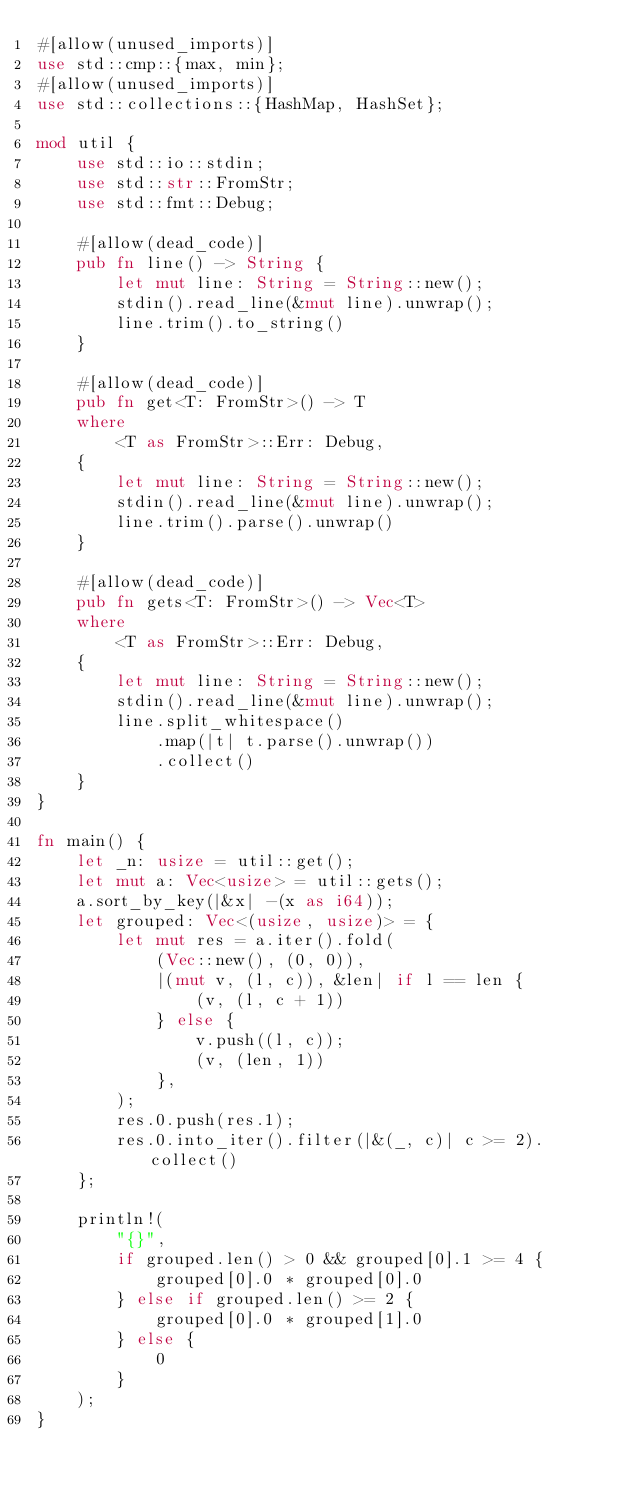Convert code to text. <code><loc_0><loc_0><loc_500><loc_500><_Rust_>#[allow(unused_imports)]
use std::cmp::{max, min};
#[allow(unused_imports)]
use std::collections::{HashMap, HashSet};

mod util {
    use std::io::stdin;
    use std::str::FromStr;
    use std::fmt::Debug;

    #[allow(dead_code)]
    pub fn line() -> String {
        let mut line: String = String::new();
        stdin().read_line(&mut line).unwrap();
        line.trim().to_string()
    }

    #[allow(dead_code)]
    pub fn get<T: FromStr>() -> T
    where
        <T as FromStr>::Err: Debug,
    {
        let mut line: String = String::new();
        stdin().read_line(&mut line).unwrap();
        line.trim().parse().unwrap()
    }

    #[allow(dead_code)]
    pub fn gets<T: FromStr>() -> Vec<T>
    where
        <T as FromStr>::Err: Debug,
    {
        let mut line: String = String::new();
        stdin().read_line(&mut line).unwrap();
        line.split_whitespace()
            .map(|t| t.parse().unwrap())
            .collect()
    }
}

fn main() {
    let _n: usize = util::get();
    let mut a: Vec<usize> = util::gets();
    a.sort_by_key(|&x| -(x as i64));
    let grouped: Vec<(usize, usize)> = {
        let mut res = a.iter().fold(
            (Vec::new(), (0, 0)),
            |(mut v, (l, c)), &len| if l == len {
                (v, (l, c + 1))
            } else {
                v.push((l, c));
                (v, (len, 1))
            },
        );
        res.0.push(res.1);
        res.0.into_iter().filter(|&(_, c)| c >= 2).collect()
    };

    println!(
        "{}",
        if grouped.len() > 0 && grouped[0].1 >= 4 {
            grouped[0].0 * grouped[0].0
        } else if grouped.len() >= 2 {
            grouped[0].0 * grouped[1].0
        } else {
            0
        }
    );
}</code> 